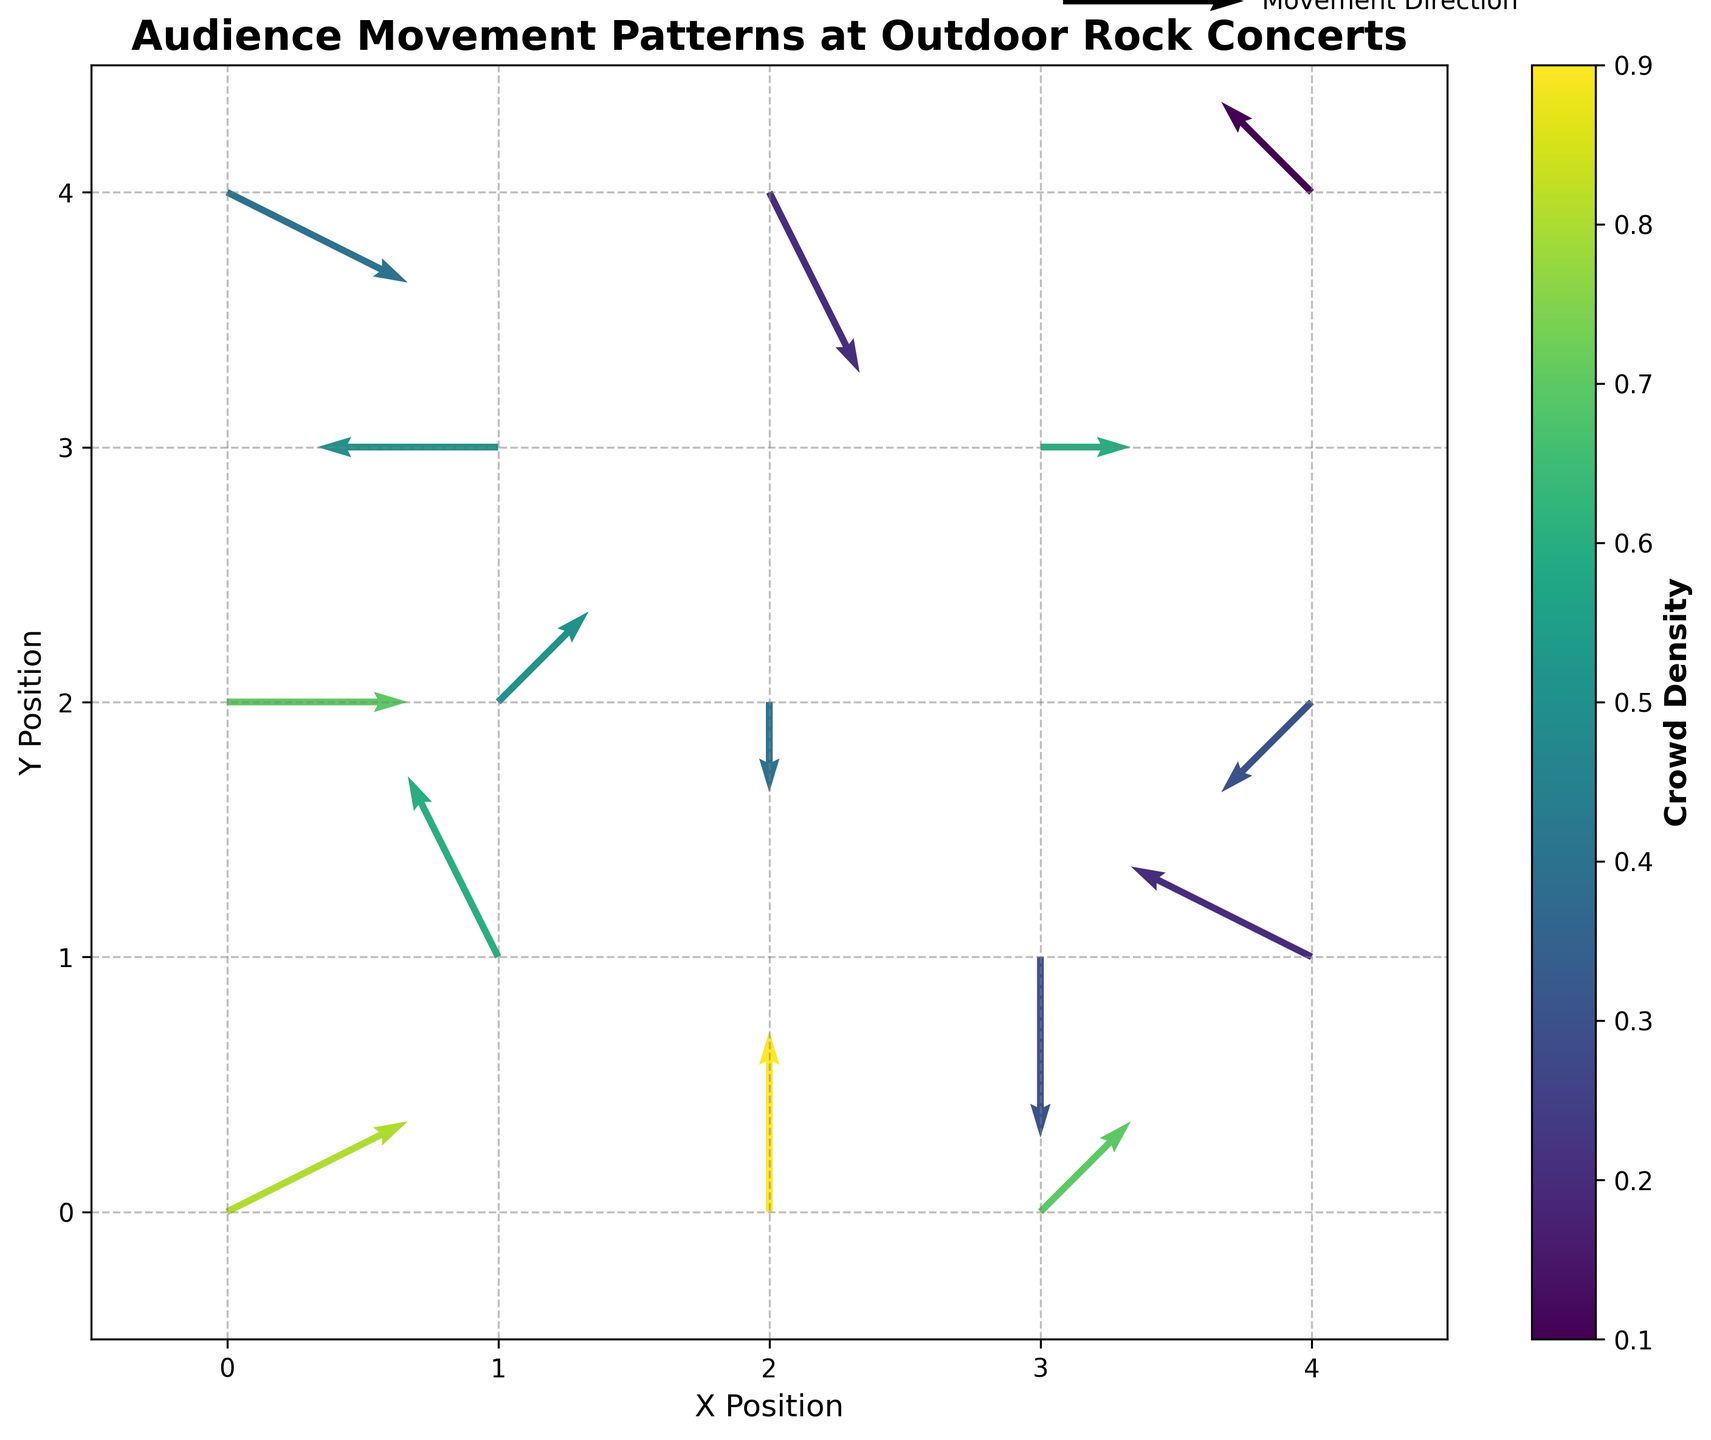What is the title of the figure? The title is usually displayed at the top of the plot. It describes the main subject of the visualization.
Answer: Audience Movement Patterns at Outdoor Rock Concerts What does the color denote in the figure? The color corresponds to the crowd density according to the color bar on the right side of the figure.
Answer: Crowd density What are the axes labeled as? The labels are found next to the x-axis and y-axis, indicating the positions they denote.
Answer: X Position and Y Position How many data points show a movement direction purely along the y-axis without any x-axis change? To find this, look for vectors with u = 0. There are two such points at (2, 2) and (3, 1).
Answer: 2 Which data point has the highest crowd density, and what is its density value? Identify the data point with the darkest color according to the color bar, which corresponds to the highest density value.
Answer: The data point at (2, 0) with a density of 0.9 Which vector indicates the largest movement based on the length of the arrow? The largest movement is determined by the vector's magnitude, found by calculating sqrt(u^2 + v^2) for each point. The vector (1, 3) → (-2, 0) is the largest.
Answer: The vector at (1, 3) If the average density of all the data points is calculated, what would it be? Sum all the density values: 0.8 + 0.6 + 0.4 + 0.7 + 0.5 + 0.3 + 0.2 + 0.4 + 0.1 + 0.9 + 0.6 + 0.5 + 0.2 + 0.7 + 0.3 = 6.2. Then, divide by the number of points, which is 15.
Answer: Approximately 0.41 Which data point shows the least density, and what is its direction of movement? Find the lightest colored vector, then check the corresponding u and v values.
Answer: The data point at (4, 4) with direction (-1, 1) Do more vectors point generally upwards, downwards, leftwards, or rightwards at first glance? Summarize the general directions. Most vectors pointing upwards have positive v, downwards have negative v, leftwards have negative u, and rightwards have positive u.
Answer: Rightwards What is the average movement vector for points with density greater than 0.5? Identify points: (0, 0), (1, 1), (3, 0), (2, 0), (3, 3), (1, 2), (0, 2). Sum u and v components separately and divide by the number of these points.
Answer: Movement vector of (0, 0.85) 